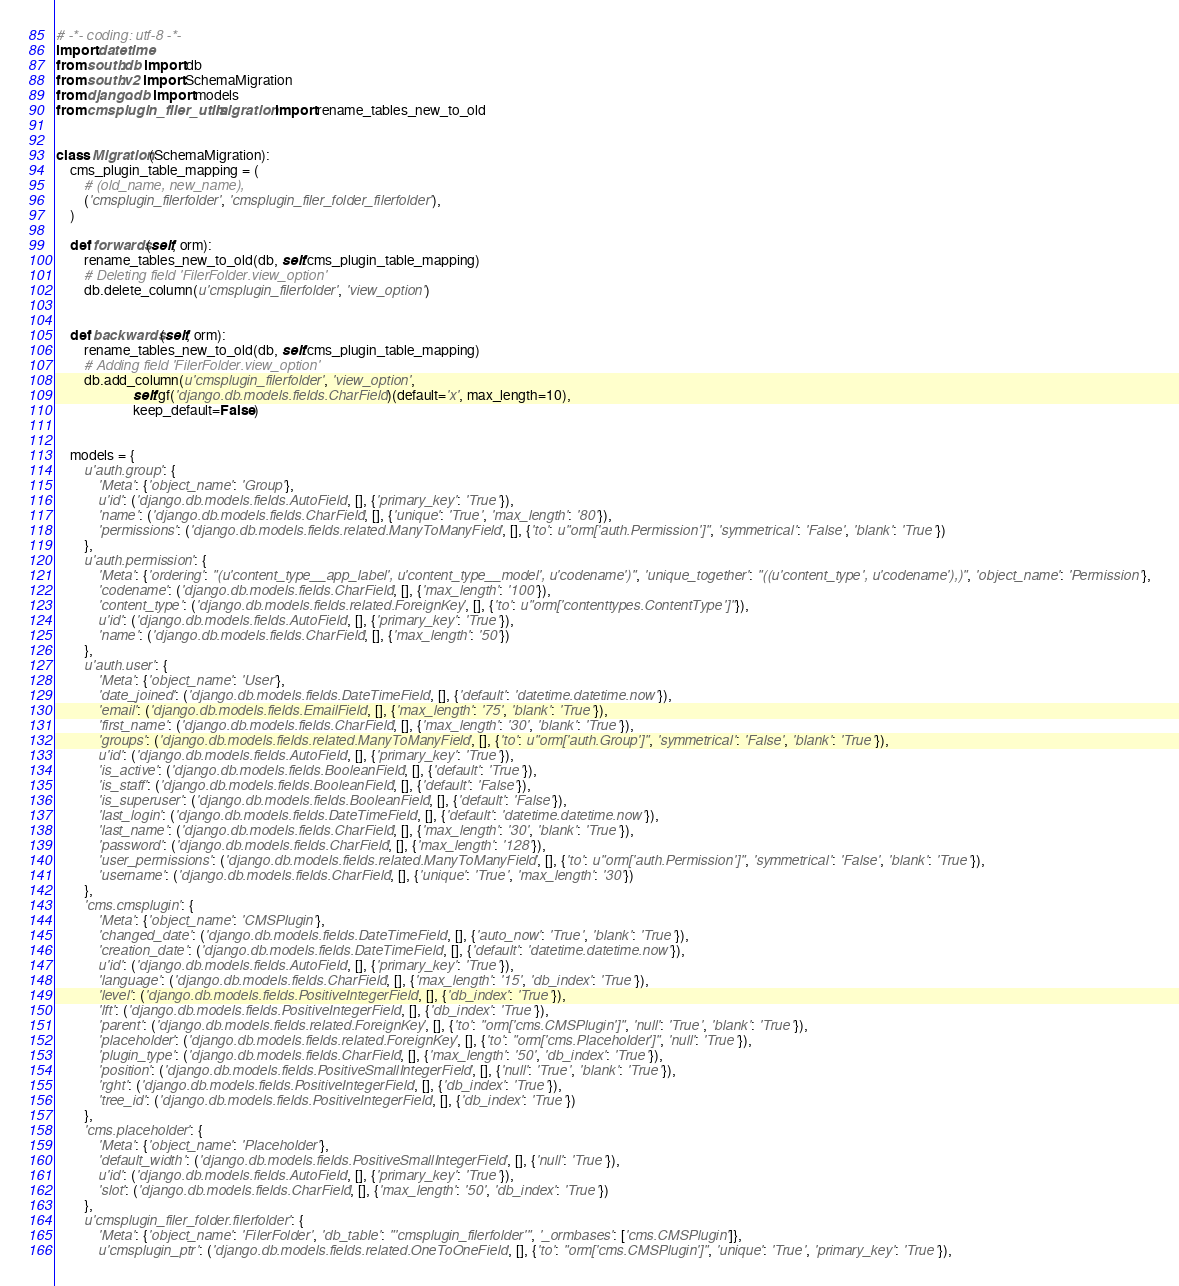Convert code to text. <code><loc_0><loc_0><loc_500><loc_500><_Python_># -*- coding: utf-8 -*-
import datetime
from south.db import db
from south.v2 import SchemaMigration
from django.db import models
from cmsplugin_filer_utils.migration import rename_tables_new_to_old


class Migration(SchemaMigration):
    cms_plugin_table_mapping = (
        # (old_name, new_name),
        ('cmsplugin_filerfolder', 'cmsplugin_filer_folder_filerfolder'),
    )

    def forwards(self, orm):
        rename_tables_new_to_old(db, self.cms_plugin_table_mapping)
        # Deleting field 'FilerFolder.view_option'
        db.delete_column(u'cmsplugin_filerfolder', 'view_option')


    def backwards(self, orm):
        rename_tables_new_to_old(db, self.cms_plugin_table_mapping)
        # Adding field 'FilerFolder.view_option'
        db.add_column(u'cmsplugin_filerfolder', 'view_option',
                      self.gf('django.db.models.fields.CharField')(default='x', max_length=10),
                      keep_default=False)


    models = {
        u'auth.group': {
            'Meta': {'object_name': 'Group'},
            u'id': ('django.db.models.fields.AutoField', [], {'primary_key': 'True'}),
            'name': ('django.db.models.fields.CharField', [], {'unique': 'True', 'max_length': '80'}),
            'permissions': ('django.db.models.fields.related.ManyToManyField', [], {'to': u"orm['auth.Permission']", 'symmetrical': 'False', 'blank': 'True'})
        },
        u'auth.permission': {
            'Meta': {'ordering': "(u'content_type__app_label', u'content_type__model', u'codename')", 'unique_together': "((u'content_type', u'codename'),)", 'object_name': 'Permission'},
            'codename': ('django.db.models.fields.CharField', [], {'max_length': '100'}),
            'content_type': ('django.db.models.fields.related.ForeignKey', [], {'to': u"orm['contenttypes.ContentType']"}),
            u'id': ('django.db.models.fields.AutoField', [], {'primary_key': 'True'}),
            'name': ('django.db.models.fields.CharField', [], {'max_length': '50'})
        },
        u'auth.user': {
            'Meta': {'object_name': 'User'},
            'date_joined': ('django.db.models.fields.DateTimeField', [], {'default': 'datetime.datetime.now'}),
            'email': ('django.db.models.fields.EmailField', [], {'max_length': '75', 'blank': 'True'}),
            'first_name': ('django.db.models.fields.CharField', [], {'max_length': '30', 'blank': 'True'}),
            'groups': ('django.db.models.fields.related.ManyToManyField', [], {'to': u"orm['auth.Group']", 'symmetrical': 'False', 'blank': 'True'}),
            u'id': ('django.db.models.fields.AutoField', [], {'primary_key': 'True'}),
            'is_active': ('django.db.models.fields.BooleanField', [], {'default': 'True'}),
            'is_staff': ('django.db.models.fields.BooleanField', [], {'default': 'False'}),
            'is_superuser': ('django.db.models.fields.BooleanField', [], {'default': 'False'}),
            'last_login': ('django.db.models.fields.DateTimeField', [], {'default': 'datetime.datetime.now'}),
            'last_name': ('django.db.models.fields.CharField', [], {'max_length': '30', 'blank': 'True'}),
            'password': ('django.db.models.fields.CharField', [], {'max_length': '128'}),
            'user_permissions': ('django.db.models.fields.related.ManyToManyField', [], {'to': u"orm['auth.Permission']", 'symmetrical': 'False', 'blank': 'True'}),
            'username': ('django.db.models.fields.CharField', [], {'unique': 'True', 'max_length': '30'})
        },
        'cms.cmsplugin': {
            'Meta': {'object_name': 'CMSPlugin'},
            'changed_date': ('django.db.models.fields.DateTimeField', [], {'auto_now': 'True', 'blank': 'True'}),
            'creation_date': ('django.db.models.fields.DateTimeField', [], {'default': 'datetime.datetime.now'}),
            u'id': ('django.db.models.fields.AutoField', [], {'primary_key': 'True'}),
            'language': ('django.db.models.fields.CharField', [], {'max_length': '15', 'db_index': 'True'}),
            'level': ('django.db.models.fields.PositiveIntegerField', [], {'db_index': 'True'}),
            'lft': ('django.db.models.fields.PositiveIntegerField', [], {'db_index': 'True'}),
            'parent': ('django.db.models.fields.related.ForeignKey', [], {'to': "orm['cms.CMSPlugin']", 'null': 'True', 'blank': 'True'}),
            'placeholder': ('django.db.models.fields.related.ForeignKey', [], {'to': "orm['cms.Placeholder']", 'null': 'True'}),
            'plugin_type': ('django.db.models.fields.CharField', [], {'max_length': '50', 'db_index': 'True'}),
            'position': ('django.db.models.fields.PositiveSmallIntegerField', [], {'null': 'True', 'blank': 'True'}),
            'rght': ('django.db.models.fields.PositiveIntegerField', [], {'db_index': 'True'}),
            'tree_id': ('django.db.models.fields.PositiveIntegerField', [], {'db_index': 'True'})
        },
        'cms.placeholder': {
            'Meta': {'object_name': 'Placeholder'},
            'default_width': ('django.db.models.fields.PositiveSmallIntegerField', [], {'null': 'True'}),
            u'id': ('django.db.models.fields.AutoField', [], {'primary_key': 'True'}),
            'slot': ('django.db.models.fields.CharField', [], {'max_length': '50', 'db_index': 'True'})
        },
        u'cmsplugin_filer_folder.filerfolder': {
            'Meta': {'object_name': 'FilerFolder', 'db_table': "'cmsplugin_filerfolder'", '_ormbases': ['cms.CMSPlugin']},
            u'cmsplugin_ptr': ('django.db.models.fields.related.OneToOneField', [], {'to': "orm['cms.CMSPlugin']", 'unique': 'True', 'primary_key': 'True'}),</code> 